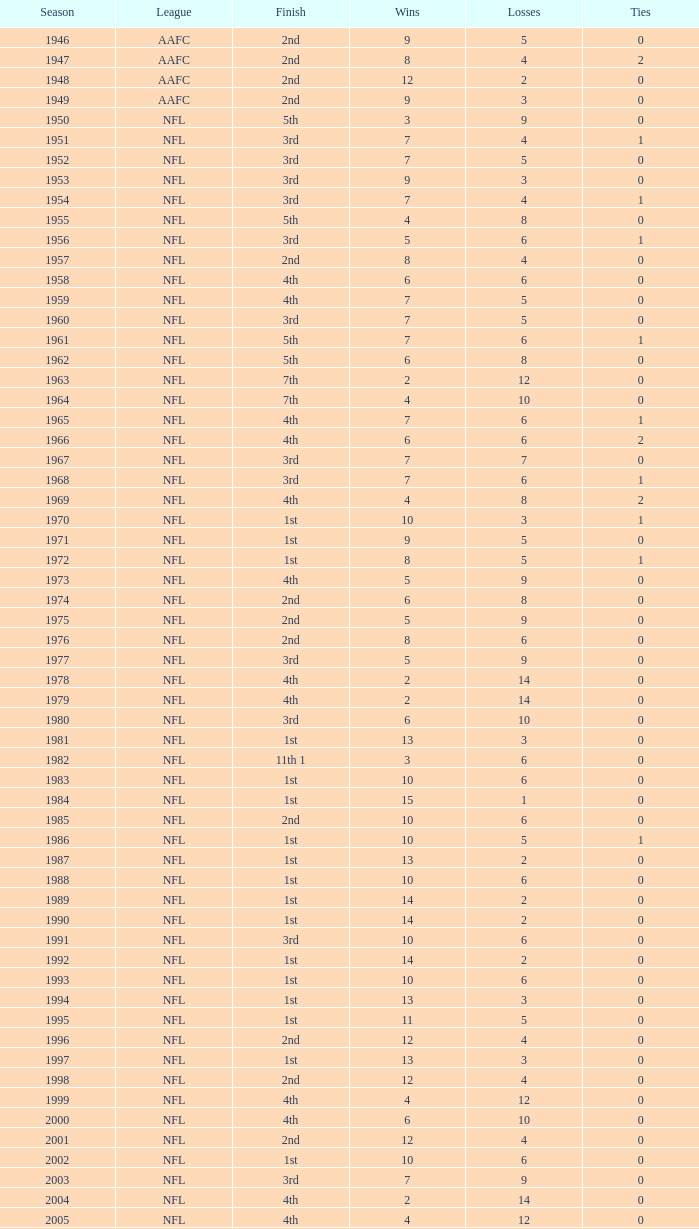In which league did a team finish 2nd with 3 losses? AAFC. 